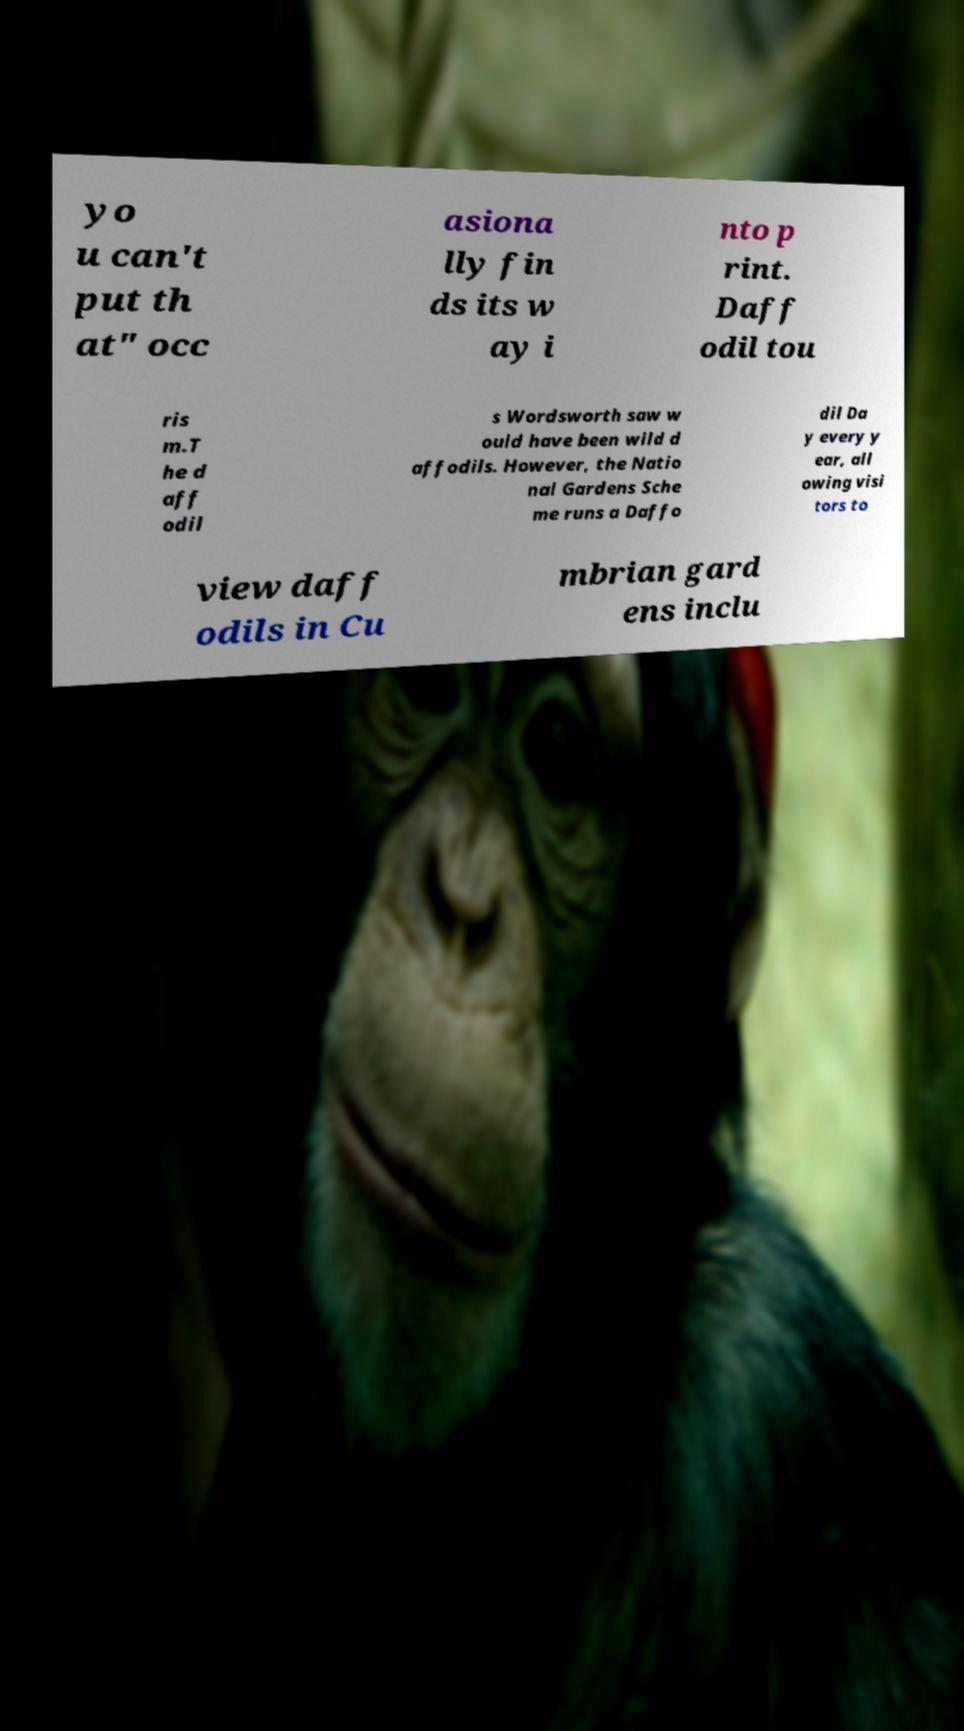Can you accurately transcribe the text from the provided image for me? yo u can't put th at" occ asiona lly fin ds its w ay i nto p rint. Daff odil tou ris m.T he d aff odil s Wordsworth saw w ould have been wild d affodils. However, the Natio nal Gardens Sche me runs a Daffo dil Da y every y ear, all owing visi tors to view daff odils in Cu mbrian gard ens inclu 